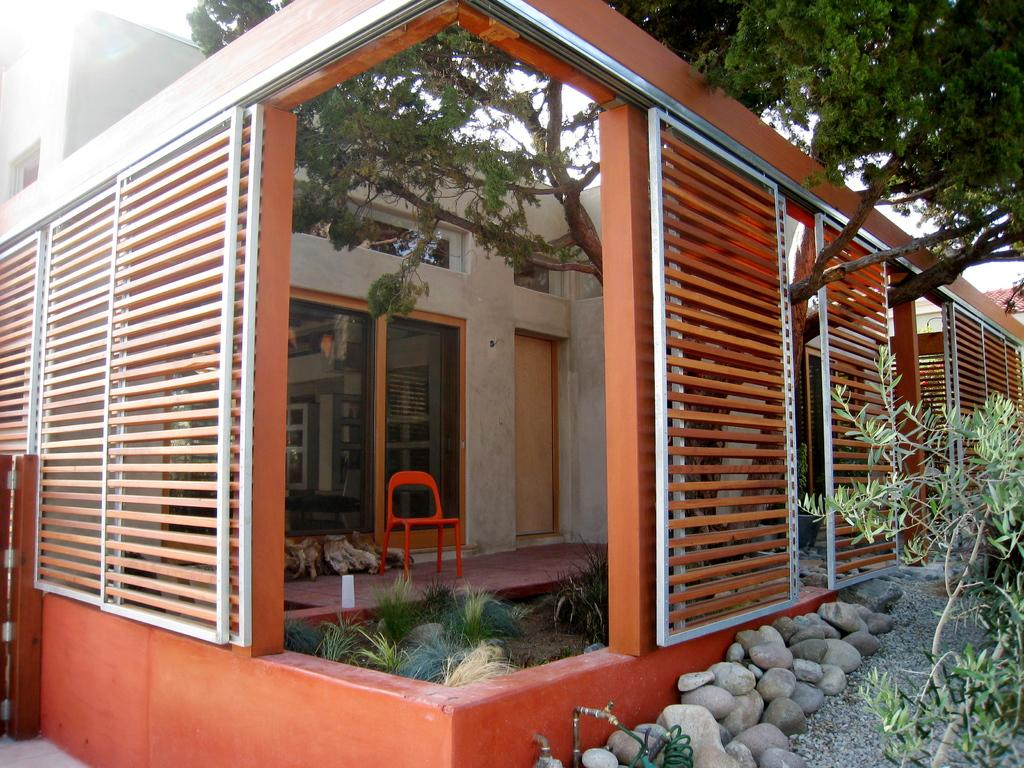What type of structure is visible in the image? There is a house in the image. What other natural elements can be seen in the image? There are plants, stones, and a tree visible in the image. What type of seating is present in the image? There is a chair in the image. What type of windows are present in the house? There are glass windows in the image. What is visible in the background of the image? The sky is visible in the background of the image. What advice does the father give to the beginner in the image? There is no father or beginner present in the image, so it is not possible to answer that question. 